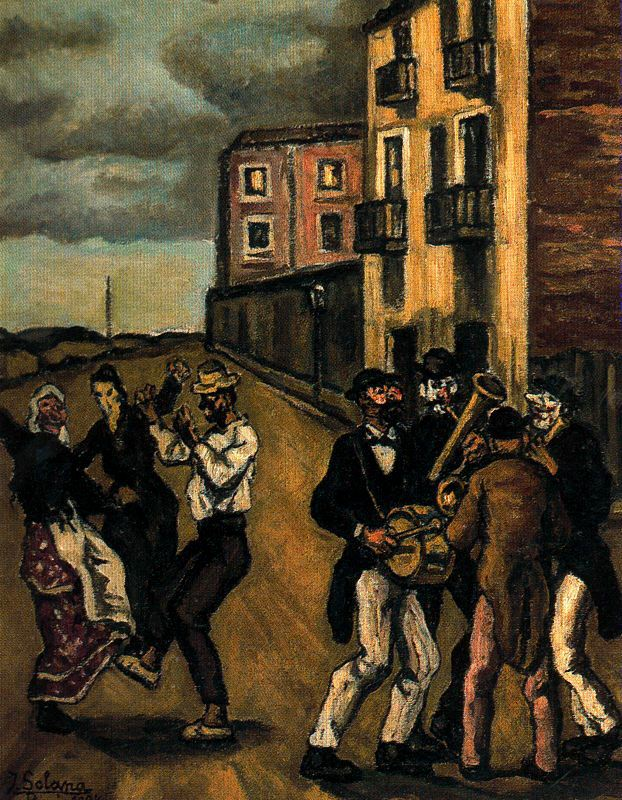What mood does the artist seem to convey in this artwork? The artist seems to convey a mood of joyous celebration and community spirit. The depiction of people dancing together in traditional attire, accompanied by live music, suggests a festive and convivial atmosphere. Despite the dark and earthy tones of the surroundings, the lively movements of the dancers and the musicians' engagement add warmth and vibrancy to the scene. Can you elaborate on the significance of the traditional clothing in this painting? The traditional clothing worn by the people in the painting serves as a significant cultural marker, highlighting the heritage and customs of the community. These garments are not only indicative of the time period but also enrich the narrative by emphasizing the importance of cultural identity and continuity. The use of traditional clothing in the painting underscores the artist's commitment to depicting everyday life and the essence of communal celebrations, making it a homage to cultural traditions and collective memory. Imagine the lives of the people in the painting once the celebration ends. What might they do next? As the celebration winds down, the people would likely return to their homes, tired yet content from the evening's festivities. The musicians, after entertaining the crowd, might pack their instruments and chat about their performance. Families would walk back together, recounting their favorite moments of the dance. Some might stop by local eateries for a late-night snack, while others might gather around a fire, sharing stories and laughter. The night would resonate with the echoes of music and joyous memories, leaving a lingering sense of community and shared joy. 